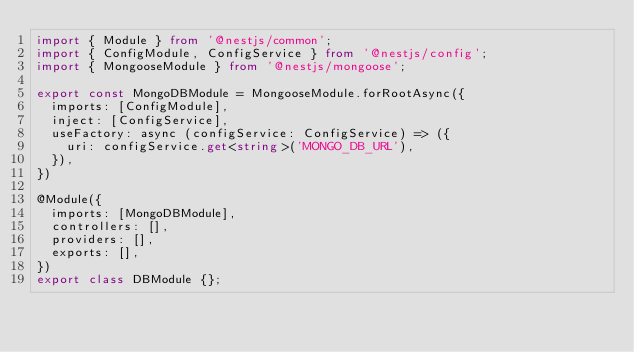<code> <loc_0><loc_0><loc_500><loc_500><_TypeScript_>import { Module } from '@nestjs/common';
import { ConfigModule, ConfigService } from '@nestjs/config';
import { MongooseModule } from '@nestjs/mongoose';

export const MongoDBModule = MongooseModule.forRootAsync({
  imports: [ConfigModule],
  inject: [ConfigService],
  useFactory: async (configService: ConfigService) => ({
    uri: configService.get<string>('MONGO_DB_URL'),
  }),
})

@Module({
  imports: [MongoDBModule],
  controllers: [],
  providers: [],
  exports: [],
})
export class DBModule {};
</code> 